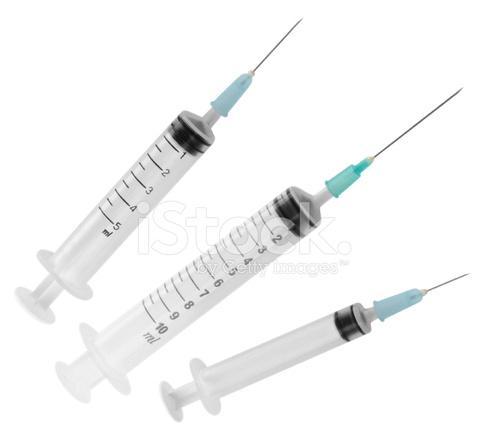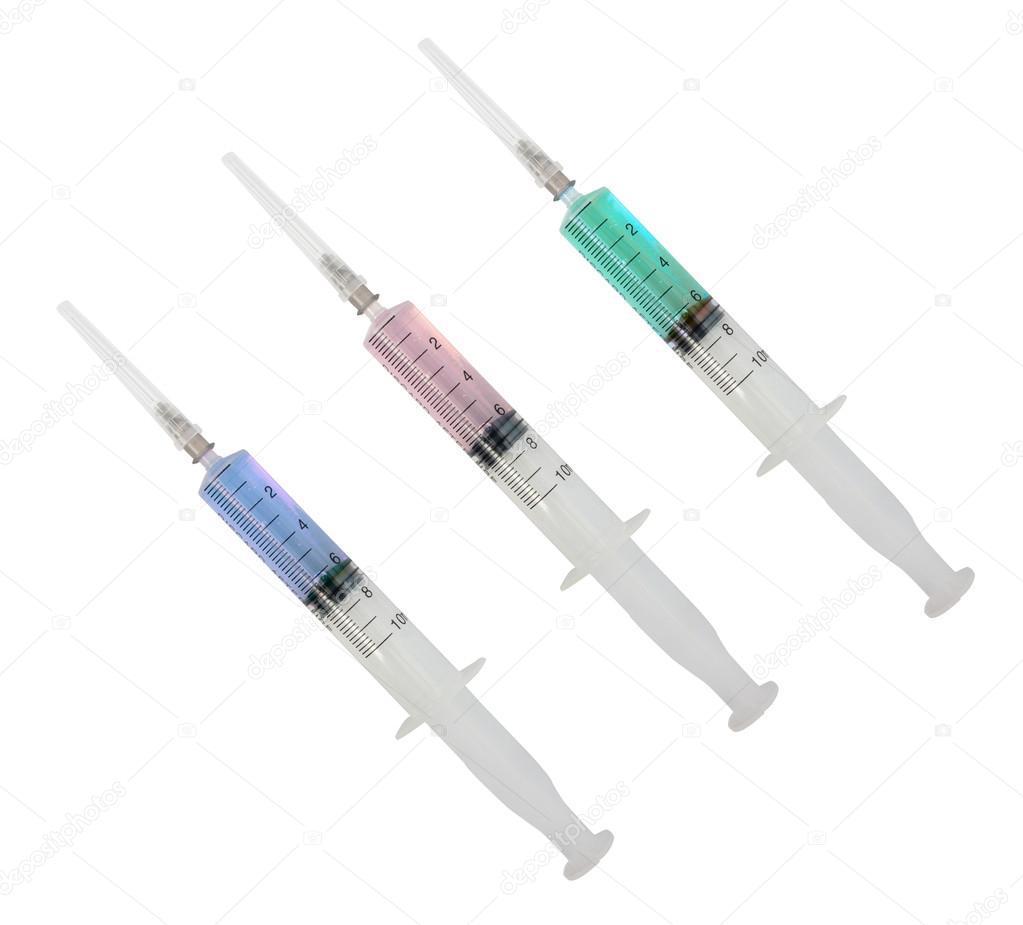The first image is the image on the left, the second image is the image on the right. Examine the images to the left and right. Is the description "The left image contains exactly three syringes." accurate? Answer yes or no. Yes. The first image is the image on the left, the second image is the image on the right. Evaluate the accuracy of this statement regarding the images: "Two or more syringes are shown with their metal needles crossed over each other in at least one of the images.". Is it true? Answer yes or no. No. 